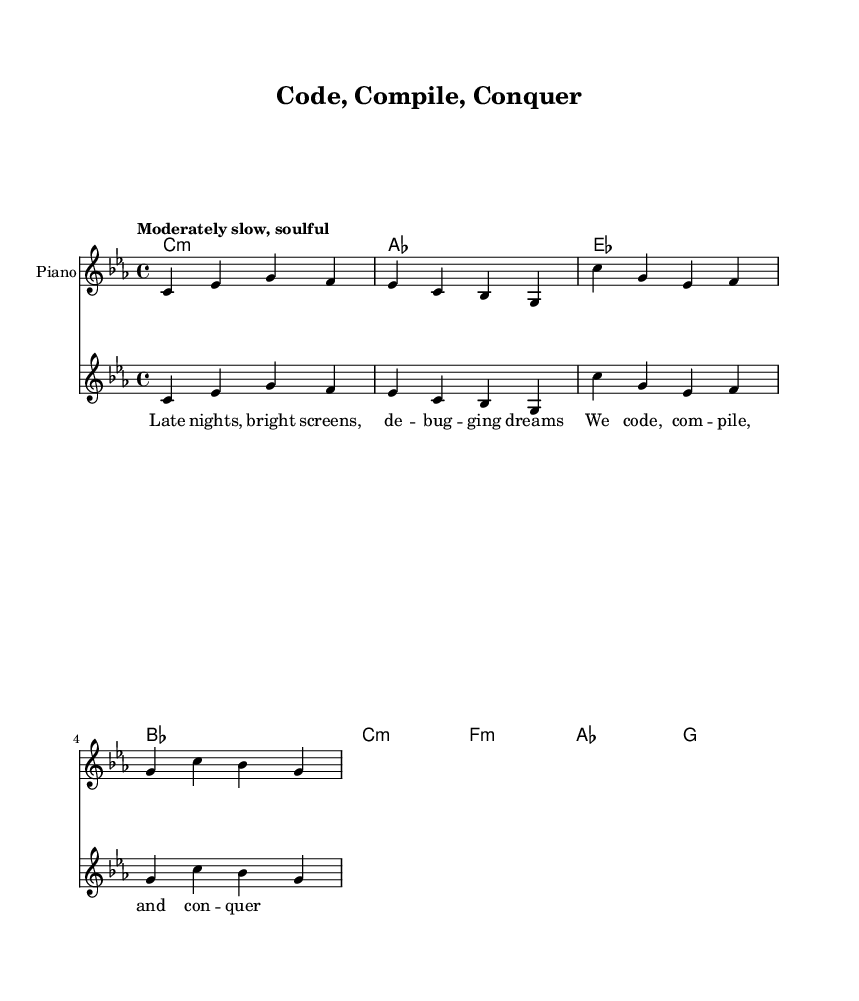What is the key signature of this music? The key signature is C minor, which is indicated by three flats in the key signature area.
Answer: C minor What is the time signature of this music? The time signature is indicated by the notation at the beginning of the staff, which shows 4 over 4, meaning there are four beats per measure and the quarter note gets one beat.
Answer: 4/4 What is the tempo marking for this piece? The tempo marking is presented as "Moderately slow, soulful," which describes the speed and feel of the music.
Answer: Moderately slow, soulful How many measures are in the verse section? By counting the measures from the melody part written for the verse, it can be seen that there are four measures.
Answer: 4 What chords are used in the chorus? The chords for the chorus can be found in the chord mode section and include C minor, F minor, A flat, and G major.
Answer: C minor, F minor, A flat, G major What is the lyrical theme of the song? The lyrics emphasize themes of dedication and perseverance in software development, depicted through expressions of late nights and debugging dreams.
Answer: Dedication and perseverance What musical genre does this piece belong to? The style and elements present in the piece, including the soulful qualities and lyrical content focused on emotional experiences in coding, classify it as a Soul genre piece.
Answer: Soul 